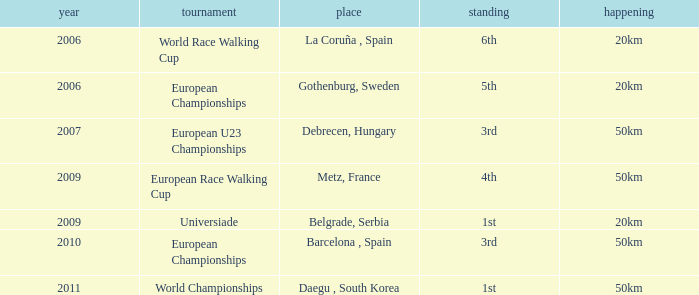Which Competition has an Event of 50km, a Year earlier than 2010 and a Position of 3rd? European U23 Championships. 